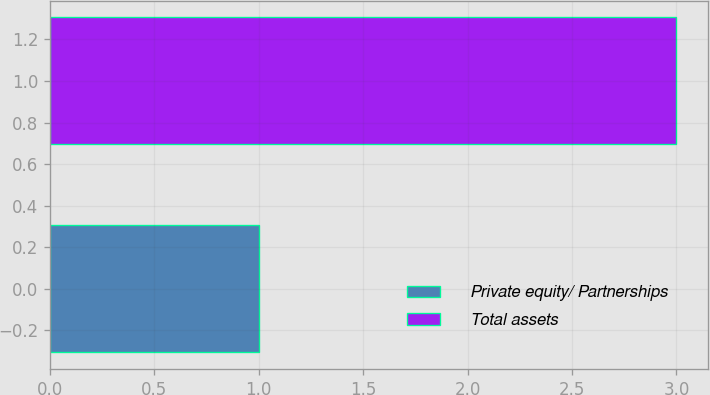Convert chart. <chart><loc_0><loc_0><loc_500><loc_500><bar_chart><fcel>Private equity/ Partnerships<fcel>Total assets<nl><fcel>1<fcel>3<nl></chart> 